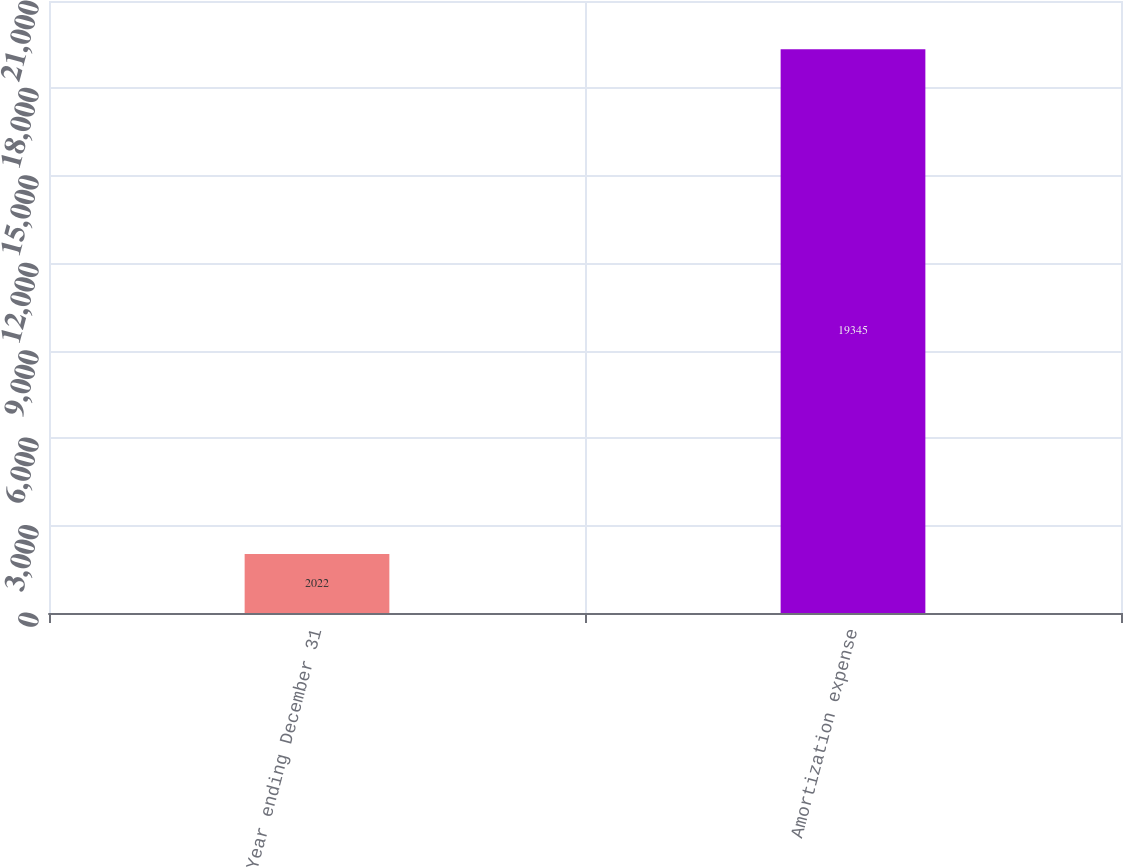<chart> <loc_0><loc_0><loc_500><loc_500><bar_chart><fcel>Year ending December 31<fcel>Amortization expense<nl><fcel>2022<fcel>19345<nl></chart> 